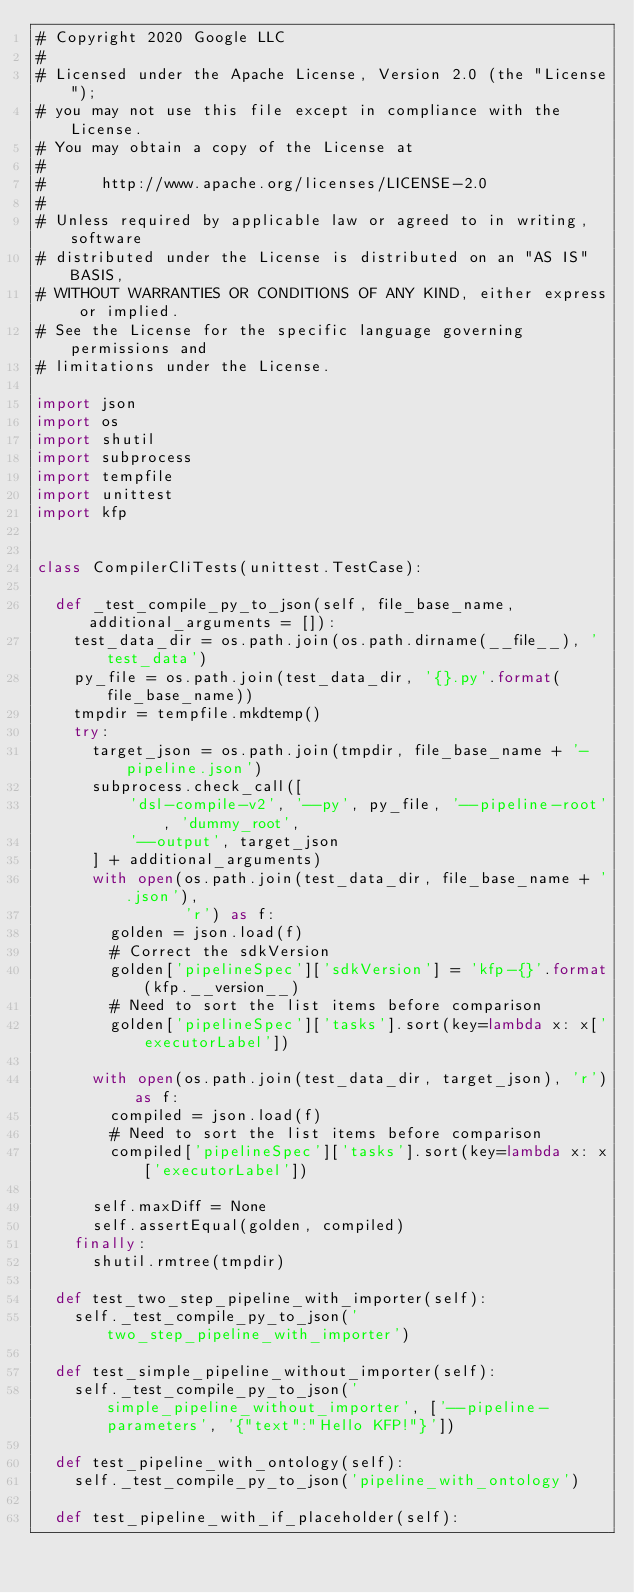Convert code to text. <code><loc_0><loc_0><loc_500><loc_500><_Python_># Copyright 2020 Google LLC
#
# Licensed under the Apache License, Version 2.0 (the "License");
# you may not use this file except in compliance with the License.
# You may obtain a copy of the License at
#
#      http://www.apache.org/licenses/LICENSE-2.0
#
# Unless required by applicable law or agreed to in writing, software
# distributed under the License is distributed on an "AS IS" BASIS,
# WITHOUT WARRANTIES OR CONDITIONS OF ANY KIND, either express or implied.
# See the License for the specific language governing permissions and
# limitations under the License.

import json
import os
import shutil
import subprocess
import tempfile
import unittest
import kfp


class CompilerCliTests(unittest.TestCase):

  def _test_compile_py_to_json(self, file_base_name, additional_arguments = []):
    test_data_dir = os.path.join(os.path.dirname(__file__), 'test_data')
    py_file = os.path.join(test_data_dir, '{}.py'.format(file_base_name))
    tmpdir = tempfile.mkdtemp()
    try:
      target_json = os.path.join(tmpdir, file_base_name + '-pipeline.json')
      subprocess.check_call([
          'dsl-compile-v2', '--py', py_file, '--pipeline-root', 'dummy_root',
          '--output', target_json
      ] + additional_arguments)
      with open(os.path.join(test_data_dir, file_base_name + '.json'),
                'r') as f:
        golden = json.load(f)
        # Correct the sdkVersion
        golden['pipelineSpec']['sdkVersion'] = 'kfp-{}'.format(kfp.__version__)
        # Need to sort the list items before comparison
        golden['pipelineSpec']['tasks'].sort(key=lambda x: x['executorLabel'])

      with open(os.path.join(test_data_dir, target_json), 'r') as f:
        compiled = json.load(f)
        # Need to sort the list items before comparison
        compiled['pipelineSpec']['tasks'].sort(key=lambda x: x['executorLabel'])

      self.maxDiff = None
      self.assertEqual(golden, compiled)
    finally:
      shutil.rmtree(tmpdir)

  def test_two_step_pipeline_with_importer(self):
    self._test_compile_py_to_json('two_step_pipeline_with_importer')

  def test_simple_pipeline_without_importer(self):
    self._test_compile_py_to_json('simple_pipeline_without_importer', ['--pipeline-parameters', '{"text":"Hello KFP!"}'])

  def test_pipeline_with_ontology(self):
    self._test_compile_py_to_json('pipeline_with_ontology')

  def test_pipeline_with_if_placeholder(self):</code> 